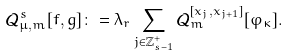<formula> <loc_0><loc_0><loc_500><loc_500>\mathcal { Q } _ { \mu , m } ^ { s } [ f , g ] \colon = \lambda _ { r } \sum _ { j \in \mathbb { Z } _ { s - 1 } ^ { + } } \mathcal { Q } _ { m } ^ { [ x _ { j } , x _ { j + 1 } ] } [ \varphi _ { \kappa } ] .</formula> 